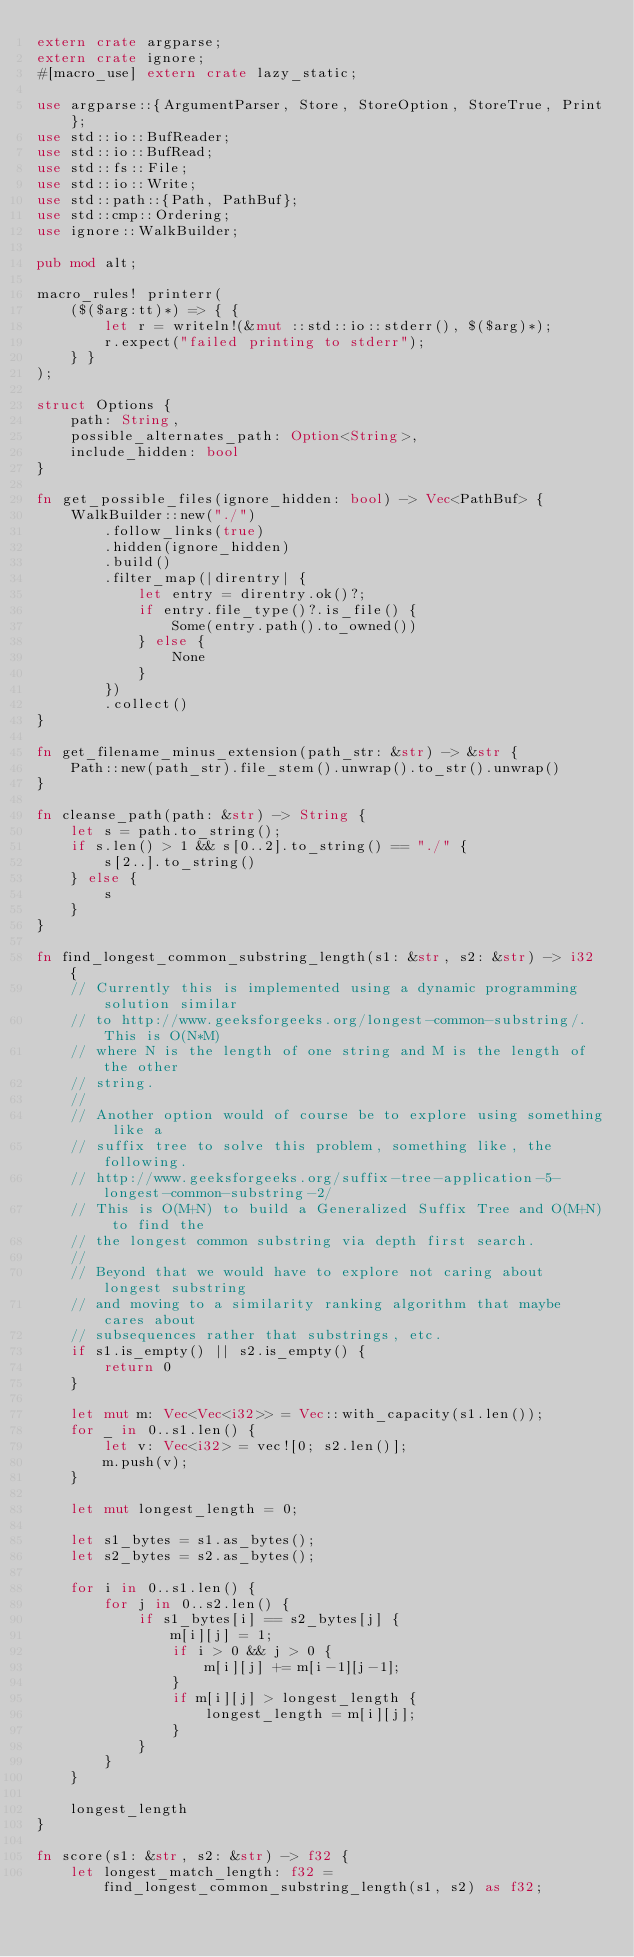<code> <loc_0><loc_0><loc_500><loc_500><_Rust_>extern crate argparse;
extern crate ignore;
#[macro_use] extern crate lazy_static;

use argparse::{ArgumentParser, Store, StoreOption, StoreTrue, Print};
use std::io::BufReader;
use std::io::BufRead;
use std::fs::File;
use std::io::Write;
use std::path::{Path, PathBuf};
use std::cmp::Ordering;
use ignore::WalkBuilder;

pub mod alt;

macro_rules! printerr(
    ($($arg:tt)*) => { {
        let r = writeln!(&mut ::std::io::stderr(), $($arg)*);
        r.expect("failed printing to stderr");
    } }
);

struct Options {
    path: String,
    possible_alternates_path: Option<String>,
    include_hidden: bool
}

fn get_possible_files(ignore_hidden: bool) -> Vec<PathBuf> {
    WalkBuilder::new("./")
        .follow_links(true)
        .hidden(ignore_hidden)
        .build()
        .filter_map(|direntry| {
            let entry = direntry.ok()?;
            if entry.file_type()?.is_file() {
                Some(entry.path().to_owned())
            } else {
                None
            }
        })
        .collect()
}

fn get_filename_minus_extension(path_str: &str) -> &str {
    Path::new(path_str).file_stem().unwrap().to_str().unwrap()
}

fn cleanse_path(path: &str) -> String {
    let s = path.to_string();
    if s.len() > 1 && s[0..2].to_string() == "./" {
        s[2..].to_string()
    } else {
        s
    }
}

fn find_longest_common_substring_length(s1: &str, s2: &str) -> i32 {
    // Currently this is implemented using a dynamic programming solution similar
    // to http://www.geeksforgeeks.org/longest-common-substring/. This is O(N*M)
    // where N is the length of one string and M is the length of the other
    // string.
    //
    // Another option would of course be to explore using something like a
    // suffix tree to solve this problem, something like, the following.
    // http://www.geeksforgeeks.org/suffix-tree-application-5-longest-common-substring-2/
    // This is O(M+N) to build a Generalized Suffix Tree and O(M+N) to find the
    // the longest common substring via depth first search.
    //
    // Beyond that we would have to explore not caring about longest substring
    // and moving to a similarity ranking algorithm that maybe cares about
    // subsequences rather that substrings, etc.
    if s1.is_empty() || s2.is_empty() {
        return 0
    }

    let mut m: Vec<Vec<i32>> = Vec::with_capacity(s1.len());
    for _ in 0..s1.len() {
        let v: Vec<i32> = vec![0; s2.len()];
        m.push(v);
    }

    let mut longest_length = 0;

    let s1_bytes = s1.as_bytes();
    let s2_bytes = s2.as_bytes();

    for i in 0..s1.len() {
        for j in 0..s2.len() {
            if s1_bytes[i] == s2_bytes[j] {
                m[i][j] = 1;
                if i > 0 && j > 0 {
                    m[i][j] += m[i-1][j-1];
                }
                if m[i][j] > longest_length {
                    longest_length = m[i][j];
                }
            }
        }
    }

    longest_length
}

fn score(s1: &str, s2: &str) -> f32 {
    let longest_match_length: f32 = find_longest_common_substring_length(s1, s2) as f32;</code> 